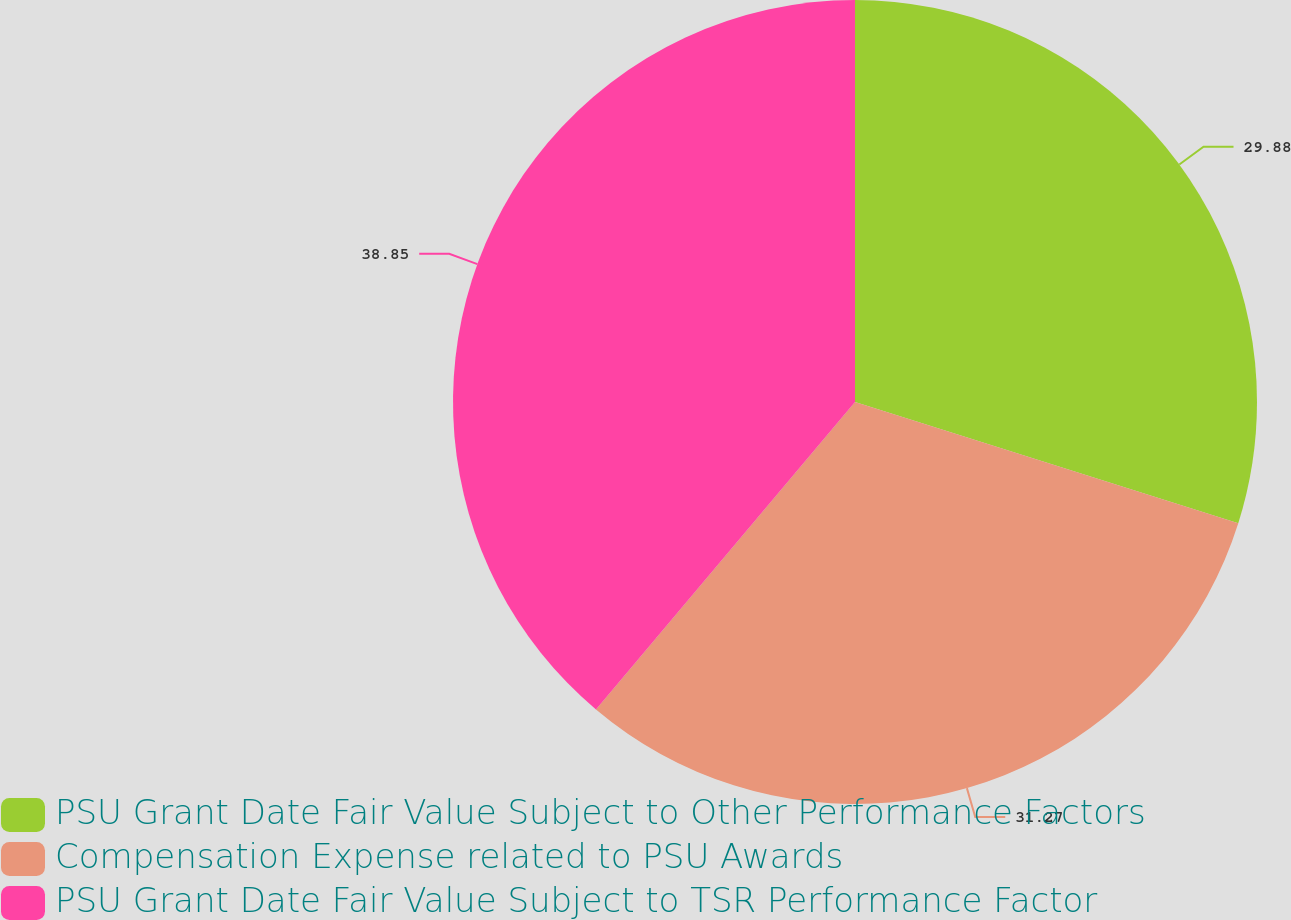Convert chart to OTSL. <chart><loc_0><loc_0><loc_500><loc_500><pie_chart><fcel>PSU Grant Date Fair Value Subject to Other Performance Factors<fcel>Compensation Expense related to PSU Awards<fcel>PSU Grant Date Fair Value Subject to TSR Performance Factor<nl><fcel>29.88%<fcel>31.27%<fcel>38.86%<nl></chart> 